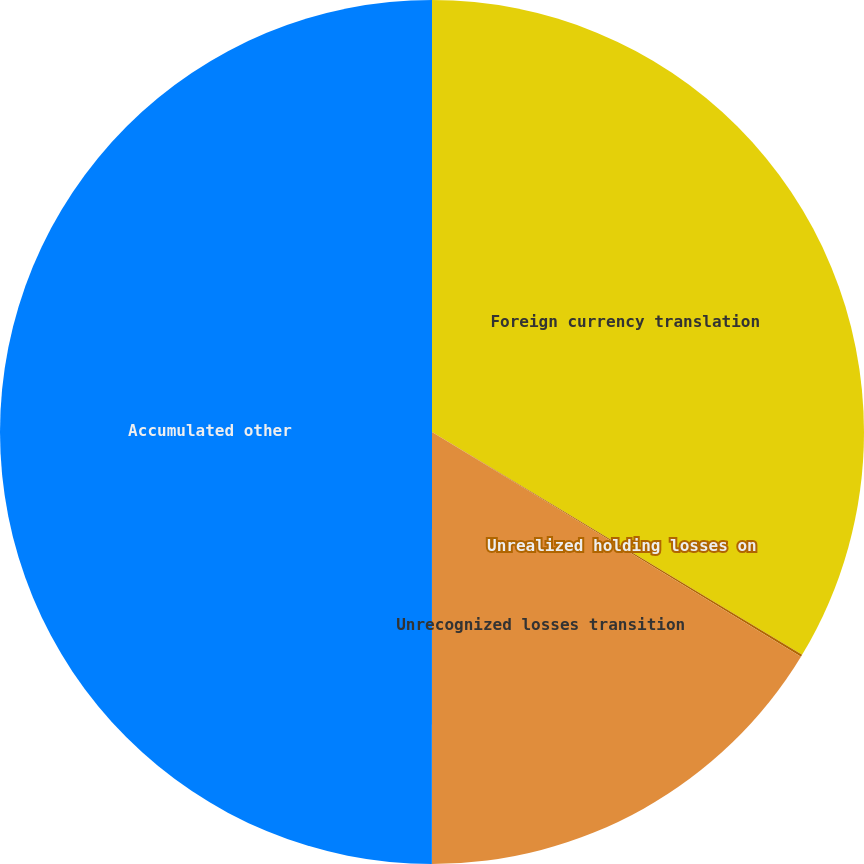<chart> <loc_0><loc_0><loc_500><loc_500><pie_chart><fcel>Foreign currency translation<fcel>Unrealized holding losses on<fcel>Unrecognized losses transition<fcel>Accumulated other<nl><fcel>33.63%<fcel>0.08%<fcel>16.3%<fcel>50.0%<nl></chart> 